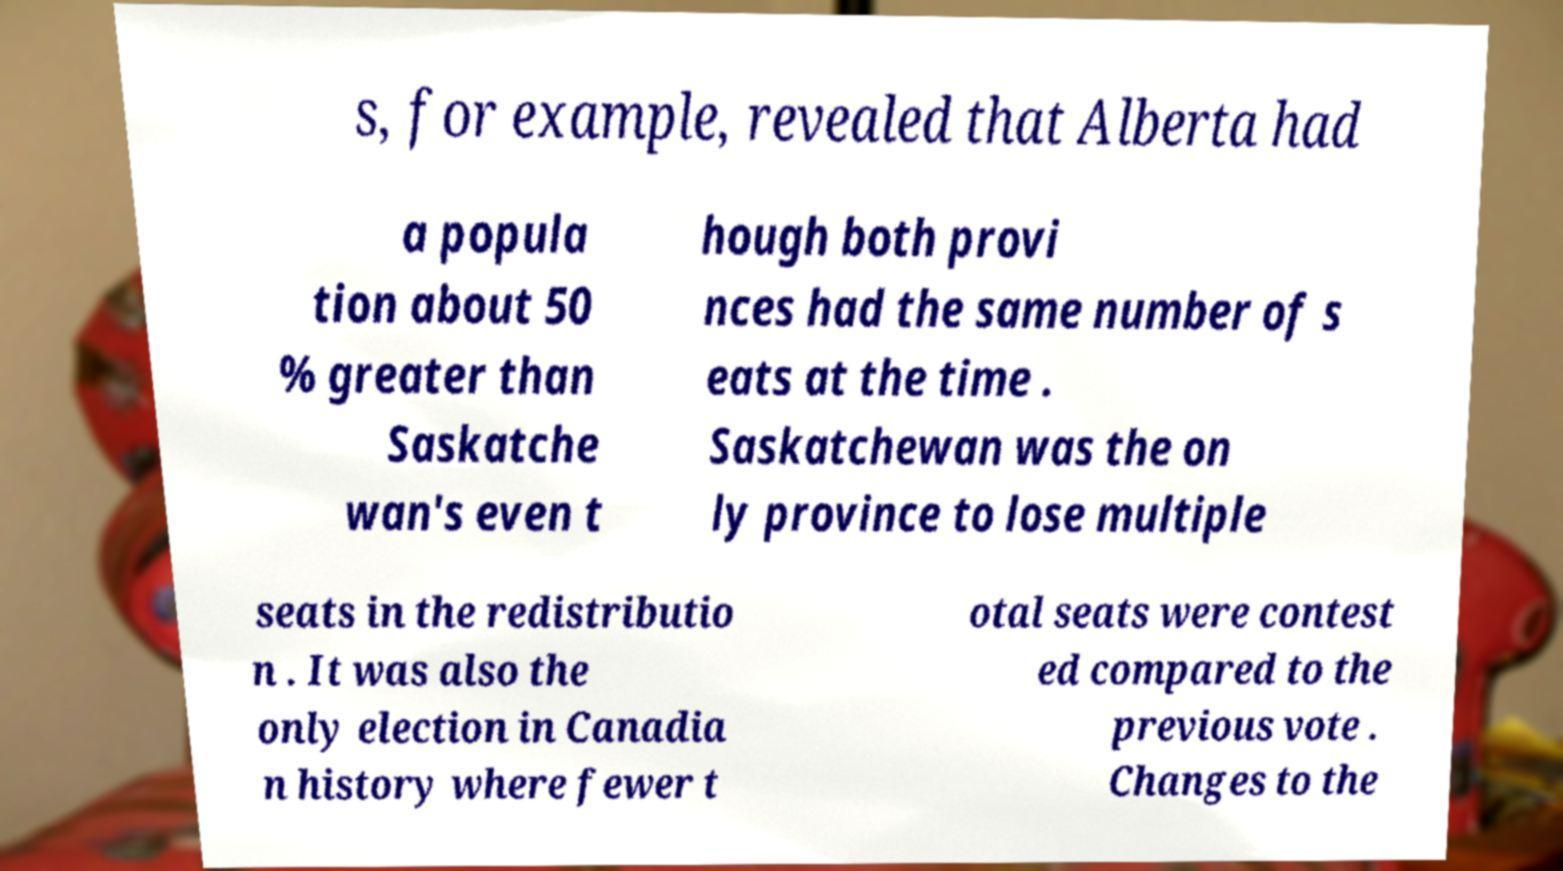What messages or text are displayed in this image? I need them in a readable, typed format. s, for example, revealed that Alberta had a popula tion about 50 % greater than Saskatche wan's even t hough both provi nces had the same number of s eats at the time . Saskatchewan was the on ly province to lose multiple seats in the redistributio n . It was also the only election in Canadia n history where fewer t otal seats were contest ed compared to the previous vote . Changes to the 